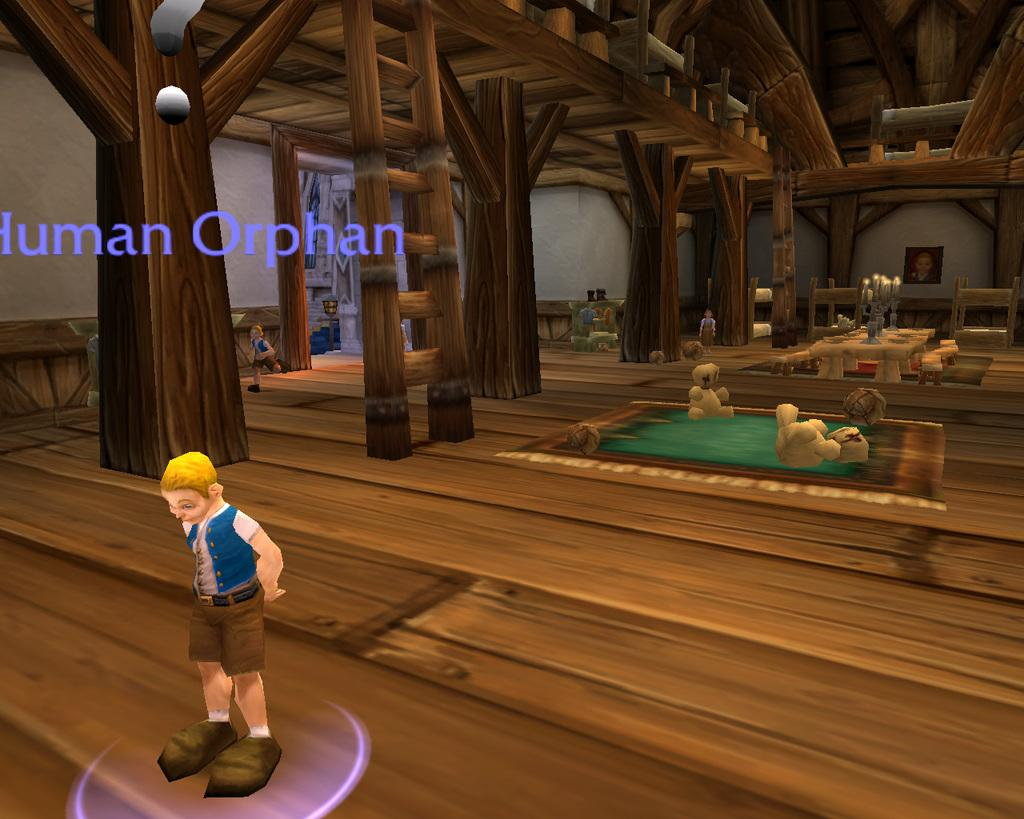What type of image is being described? The image is animated. What kind of structure can be seen in the image? There is a wooden house in the image. What else is present in the image besides the wooden house? There are toys and three kids in the image. Is there any text visible in the image? Yes, there is some text on the left side of the image. What type of army is depicted in the image? There is no army present in the image; it features an animated scene with a wooden house, toys, and kids. What do the kids in the image believe in? The image does not provide information about the kids' beliefs or opinions. 